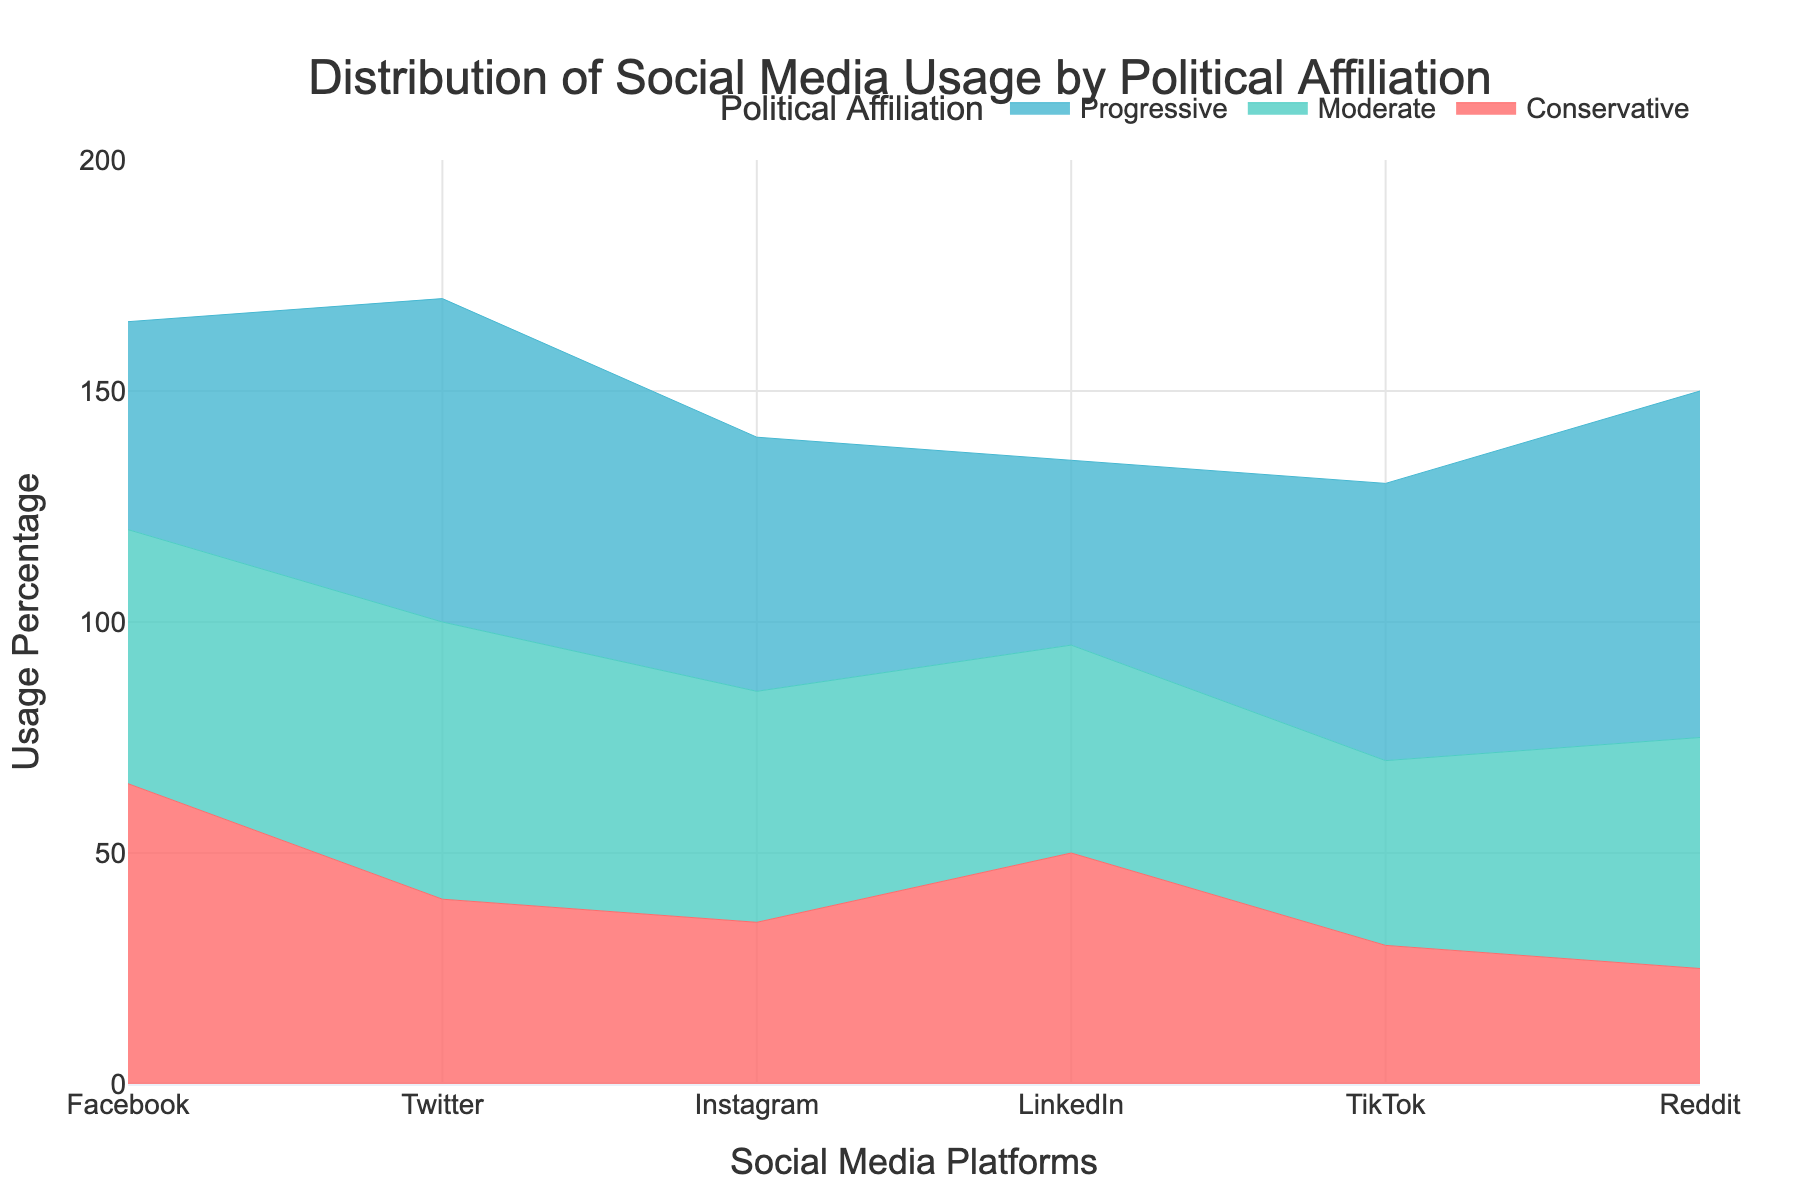What social media platform do Progressives use the most? To identify the most-used platform by Progressives, we look at the highest data point in the Progressive area section. The highest usage percentage is 75% for Reddit.
Answer: Reddit Which political affiliation uses Facebook the most? To determine this, we look at the heights of the areas above Facebook. The highest point is the red area, representing Conservatives, with 65%.
Answer: Conservatives What is the combined percentage usage of Instagram for all political affiliations? Sum the percentages for Instagram from all affiliations: 55% (Progressive) + 50% (Moderate) + 35% (Conservative) = 140%.
Answer: 140% Is Twitter more popular among Progressives or Conservatives, and by how much? We compare the heights of the Twitter segments for Progressives and Conservatives. Progressives have 70%, while Conservatives have 40%. The difference is 70% - 40% = 30%.
Answer: Progressives by 30% What is the average usage percentage of TikTok across all political affiliations? To find the average usage, sum the percentages for TikTok and divide by the number of affiliations: (60% + 40% + 30%) / 3 = 130% / 3 ≈ 43.33%.
Answer: 43.33% Which social media platform has the most balanced usage among all political affiliations? Look for the platform where the heights of the colored sections are most similar. LinkedIn's usage is between 40% and 50% across all affiliations, making it the most balanced.
Answer: LinkedIn Which social media platform is least used by Conservatives? Identify the lowest point in the Conservative area. The lowest is TikTok at 30%.
Answer: TikTok How much more do Moderates use Facebook compared to TikTok? Compare the heights of the Moderate segments for Facebook and TikTok. Facebook has 55%, and TikTok has 40%. The difference is 55% - 40% = 15%.
Answer: 15% On which social media platform is the difference between Progressive and Conservative usage the greatest? Calculate the differences for each platform: Facebook (20%), Twitter (30%), Instagram (20%), LinkedIn (10%), TikTok (30%), Reddit (50%). The greatest difference is for Reddit with 50%.
Answer: Reddit 